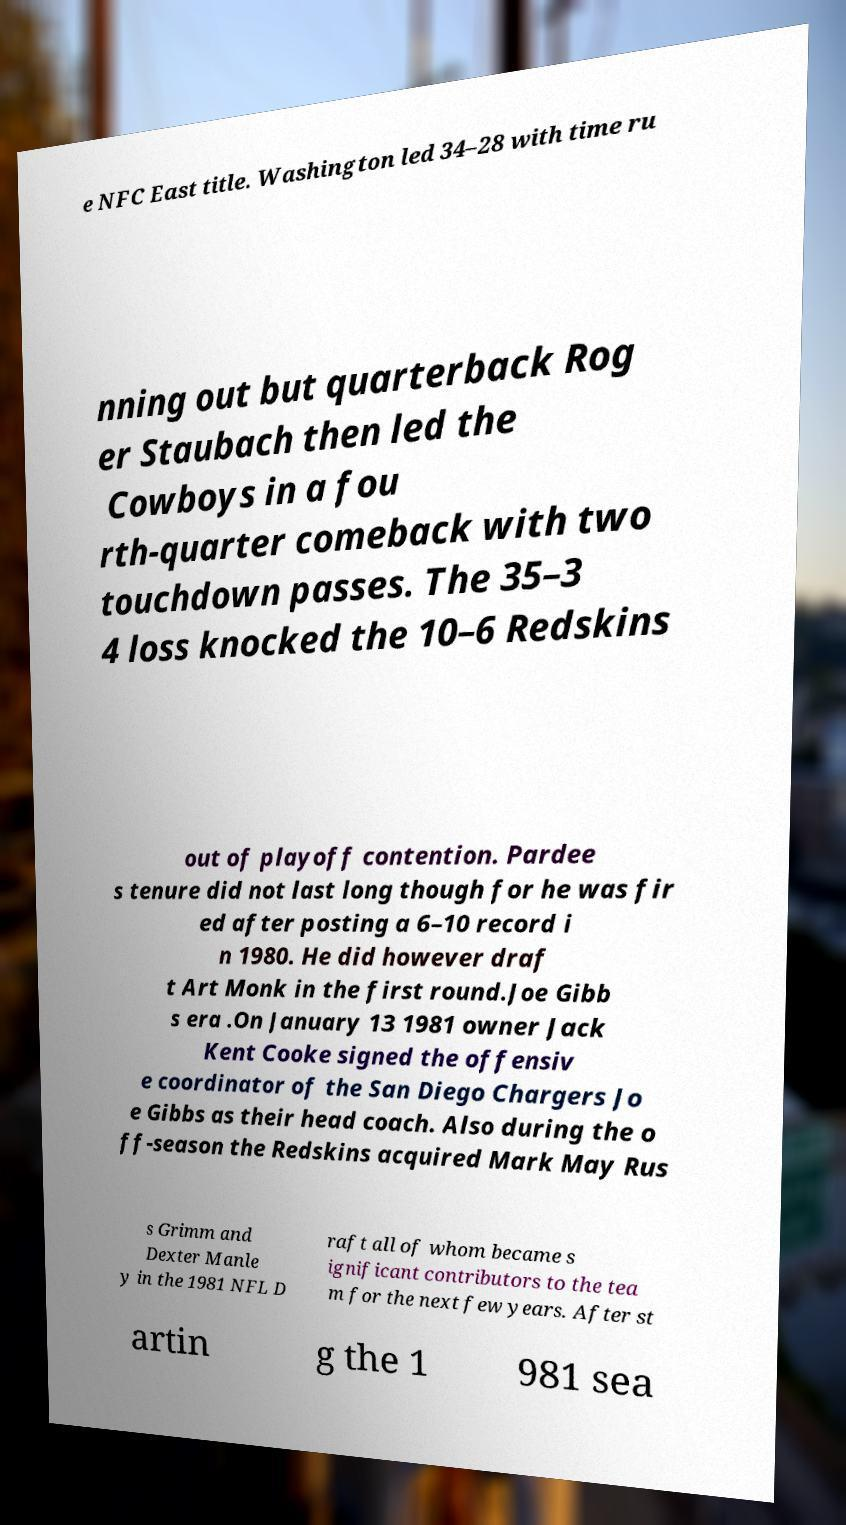Please identify and transcribe the text found in this image. e NFC East title. Washington led 34–28 with time ru nning out but quarterback Rog er Staubach then led the Cowboys in a fou rth-quarter comeback with two touchdown passes. The 35–3 4 loss knocked the 10–6 Redskins out of playoff contention. Pardee s tenure did not last long though for he was fir ed after posting a 6–10 record i n 1980. He did however draf t Art Monk in the first round.Joe Gibb s era .On January 13 1981 owner Jack Kent Cooke signed the offensiv e coordinator of the San Diego Chargers Jo e Gibbs as their head coach. Also during the o ff-season the Redskins acquired Mark May Rus s Grimm and Dexter Manle y in the 1981 NFL D raft all of whom became s ignificant contributors to the tea m for the next few years. After st artin g the 1 981 sea 